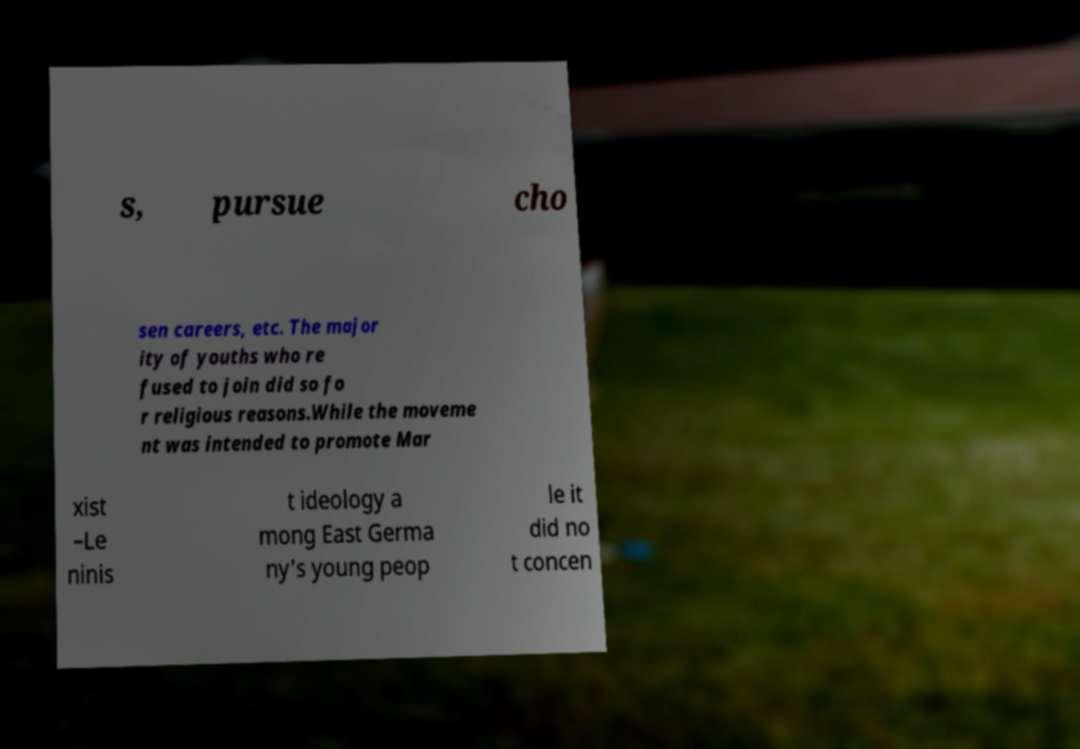I need the written content from this picture converted into text. Can you do that? s, pursue cho sen careers, etc. The major ity of youths who re fused to join did so fo r religious reasons.While the moveme nt was intended to promote Mar xist –Le ninis t ideology a mong East Germa ny's young peop le it did no t concen 